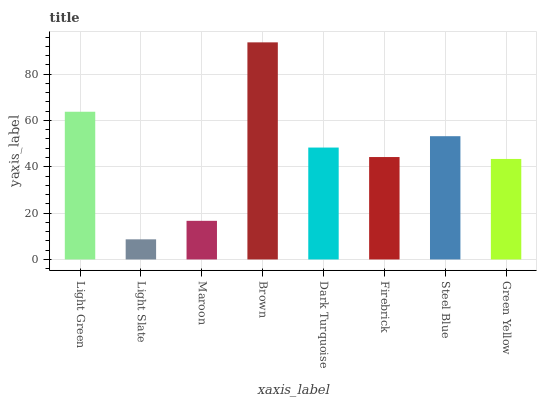Is Light Slate the minimum?
Answer yes or no. Yes. Is Brown the maximum?
Answer yes or no. Yes. Is Maroon the minimum?
Answer yes or no. No. Is Maroon the maximum?
Answer yes or no. No. Is Maroon greater than Light Slate?
Answer yes or no. Yes. Is Light Slate less than Maroon?
Answer yes or no. Yes. Is Light Slate greater than Maroon?
Answer yes or no. No. Is Maroon less than Light Slate?
Answer yes or no. No. Is Dark Turquoise the high median?
Answer yes or no. Yes. Is Firebrick the low median?
Answer yes or no. Yes. Is Light Green the high median?
Answer yes or no. No. Is Light Green the low median?
Answer yes or no. No. 